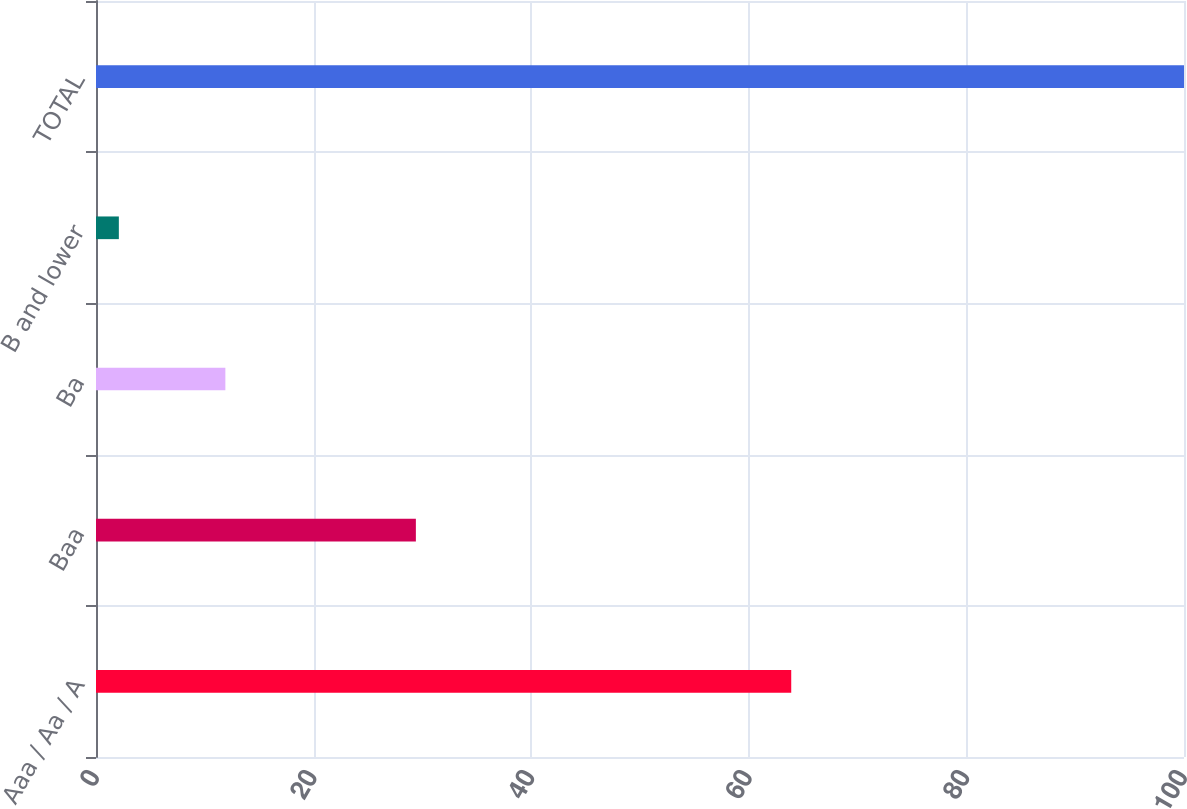Convert chart. <chart><loc_0><loc_0><loc_500><loc_500><bar_chart><fcel>Aaa / Aa / A<fcel>Baa<fcel>Ba<fcel>B and lower<fcel>TOTAL<nl><fcel>63.9<fcel>29.4<fcel>11.89<fcel>2.1<fcel>100<nl></chart> 